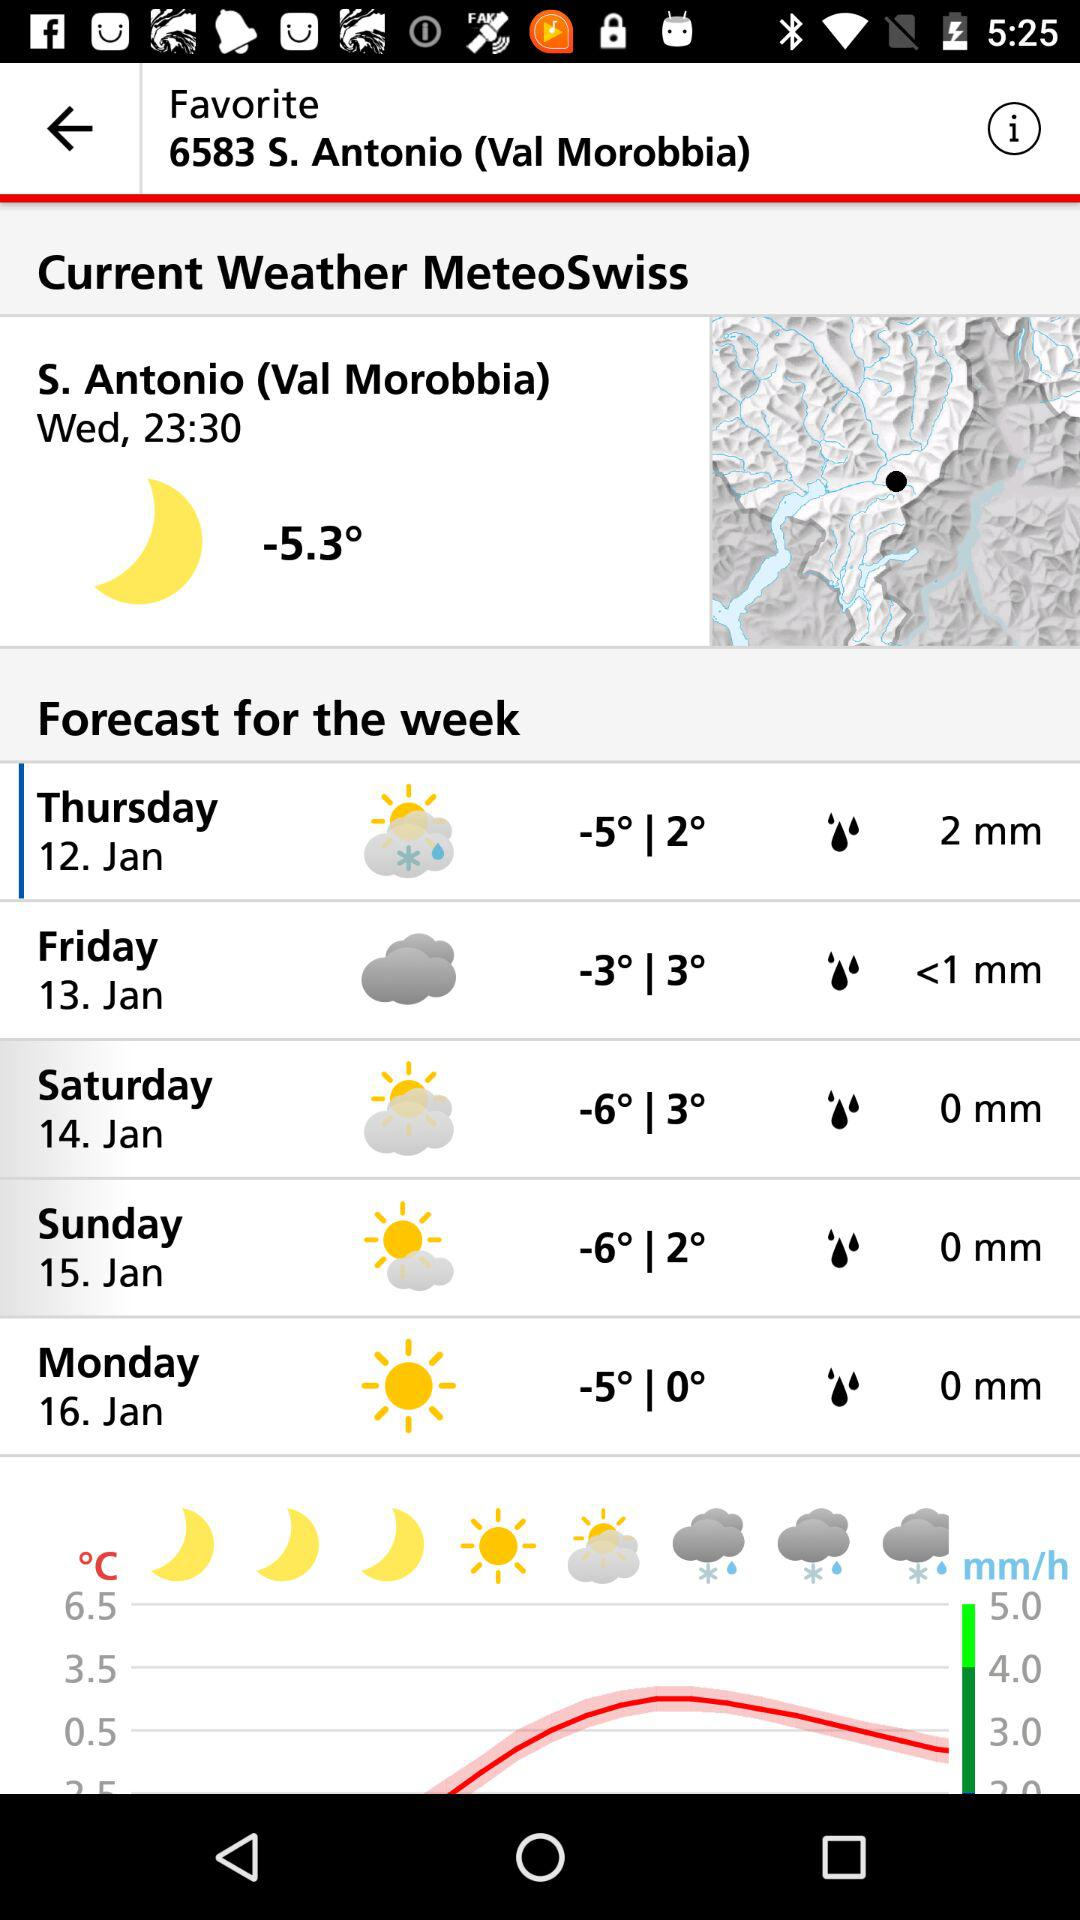What is the amount of precipitation estimated for Saturday? The amount of precipitation estimated for Saturday is 0 mm. 